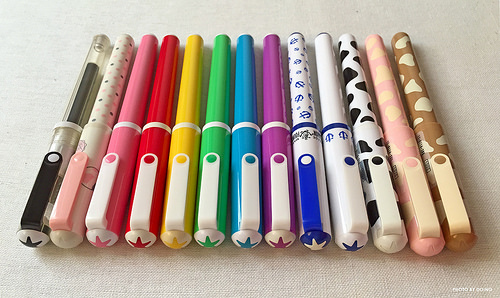<image>
Is the pink marker next to the red marker? Yes. The pink marker is positioned adjacent to the red marker, located nearby in the same general area. 